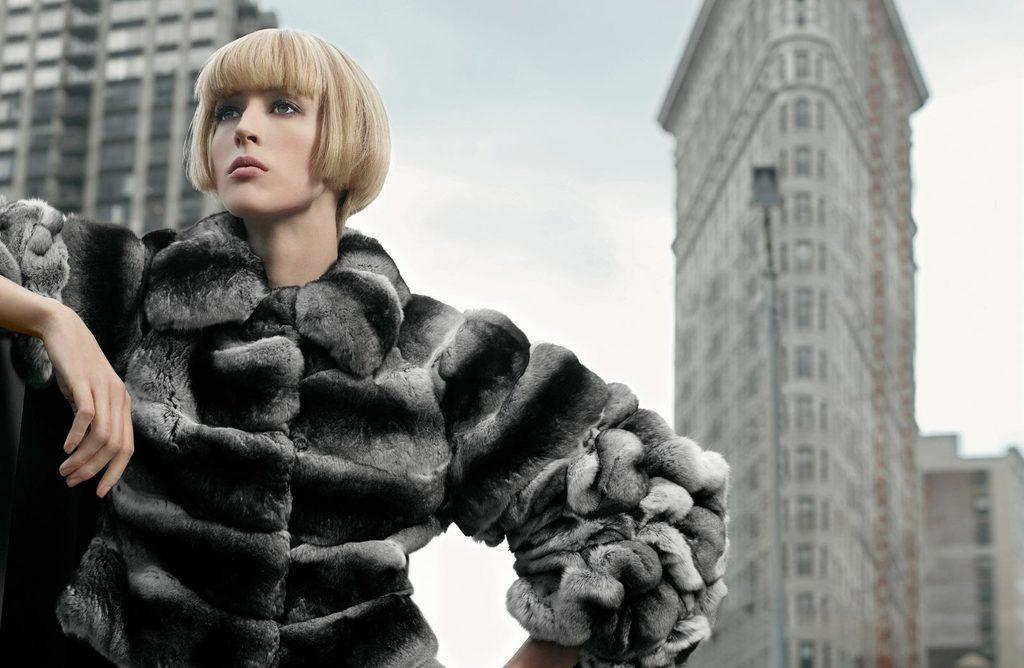Who is present in the image? There is a woman in the image. What is the woman doing in the image? The woman is standing. What can be seen in the background of the image? There are buildings, street poles, and the sky visible in the background of the image. What type of notebook is the woman holding in the image? There is no notebook present in the image. How many cameras can be seen in the image? There are no cameras visible in the image. 